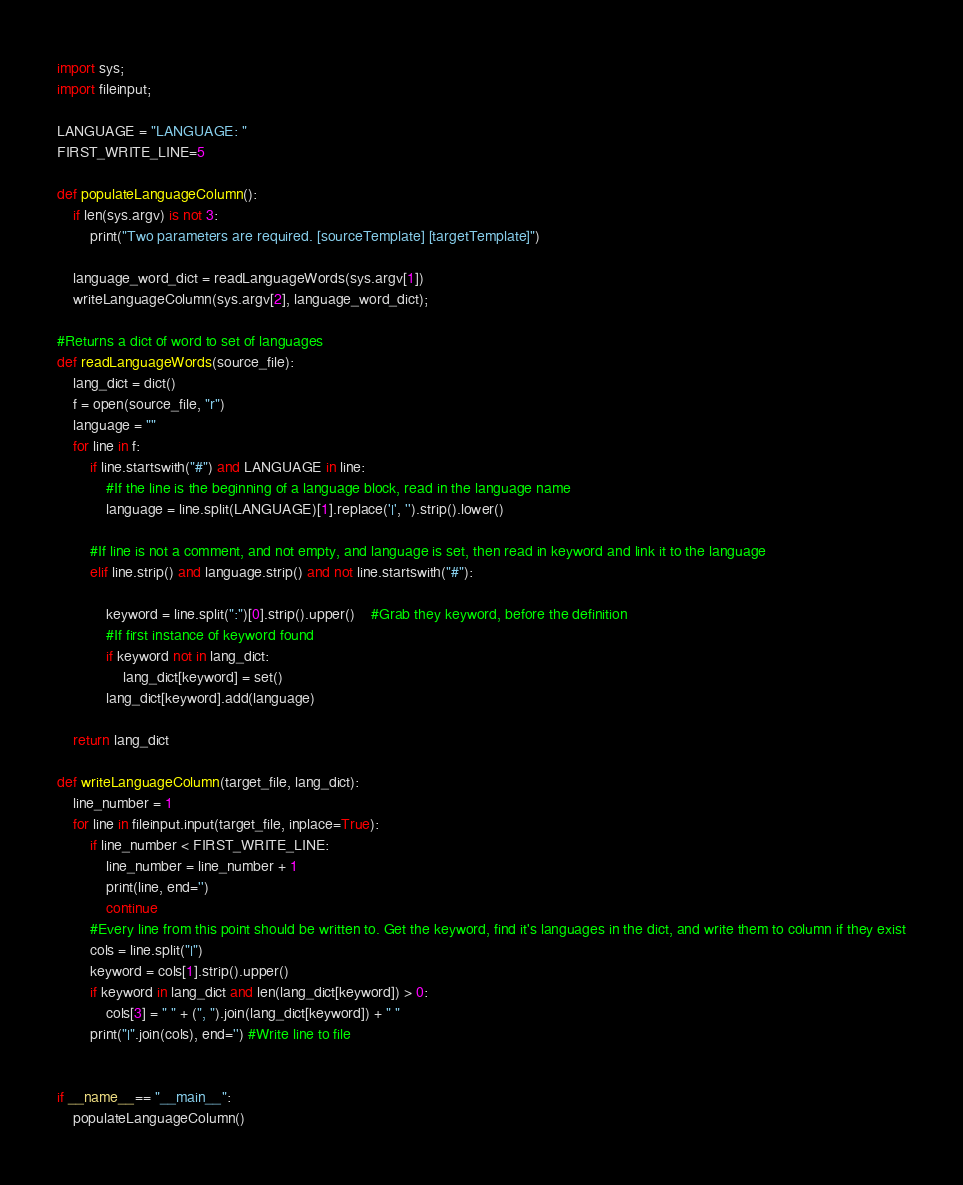<code> <loc_0><loc_0><loc_500><loc_500><_Python_>import sys;
import fileinput;

LANGUAGE = "LANGUAGE: "
FIRST_WRITE_LINE=5

def populateLanguageColumn():
    if len(sys.argv) is not 3:
        print("Two parameters are required. [sourceTemplate] [targetTemplate]")

    language_word_dict = readLanguageWords(sys.argv[1])
    writeLanguageColumn(sys.argv[2], language_word_dict);

#Returns a dict of word to set of languages
def readLanguageWords(source_file):
    lang_dict = dict()
    f = open(source_file, "r")
    language = ""
    for line in f:
        if line.startswith("#") and LANGUAGE in line:
            #If the line is the beginning of a language block, read in the language name
            language = line.split(LANGUAGE)[1].replace('|', '').strip().lower()

        #If line is not a comment, and not empty, and language is set, then read in keyword and link it to the language
        elif line.strip() and language.strip() and not line.startswith("#"):

            keyword = line.split(":")[0].strip().upper()    #Grab they keyword, before the definition
            #If first instance of keyword found
            if keyword not in lang_dict:
                lang_dict[keyword] = set()
            lang_dict[keyword].add(language)

    return lang_dict

def writeLanguageColumn(target_file, lang_dict):
    line_number = 1
    for line in fileinput.input(target_file, inplace=True):
        if line_number < FIRST_WRITE_LINE:
            line_number = line_number + 1
            print(line, end='')
            continue
        #Every line from this point should be written to. Get the keyword, find it's languages in the dict, and write them to column if they exist
        cols = line.split("|")
        keyword = cols[1].strip().upper()
        if keyword in lang_dict and len(lang_dict[keyword]) > 0:
            cols[3] = " " + (", ").join(lang_dict[keyword]) + " "
        print("|".join(cols), end='') #Write line to file


if __name__== "__main__":
    populateLanguageColumn()
</code> 